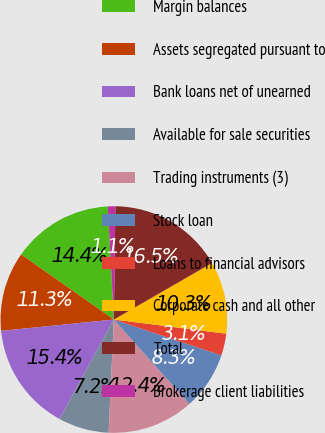<chart> <loc_0><loc_0><loc_500><loc_500><pie_chart><fcel>Margin balances<fcel>Assets segregated pursuant to<fcel>Bank loans net of unearned<fcel>Available for sale securities<fcel>Trading instruments (3)<fcel>Stock loan<fcel>Loans to financial advisors<fcel>Corporate cash and all other<fcel>Total<fcel>Brokerage client liabilities<nl><fcel>14.41%<fcel>11.33%<fcel>15.44%<fcel>7.23%<fcel>12.36%<fcel>8.26%<fcel>3.12%<fcel>10.31%<fcel>16.47%<fcel>1.07%<nl></chart> 